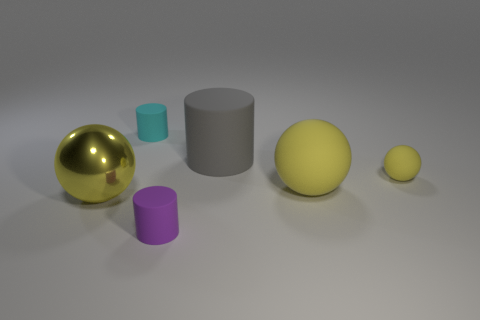How many yellow balls must be subtracted to get 1 yellow balls? 2 Add 2 small yellow matte spheres. How many objects exist? 8 Subtract 0 gray cubes. How many objects are left? 6 Subtract all tiny cyan metallic balls. Subtract all gray cylinders. How many objects are left? 5 Add 3 yellow matte spheres. How many yellow matte spheres are left? 5 Add 6 big matte cylinders. How many big matte cylinders exist? 7 